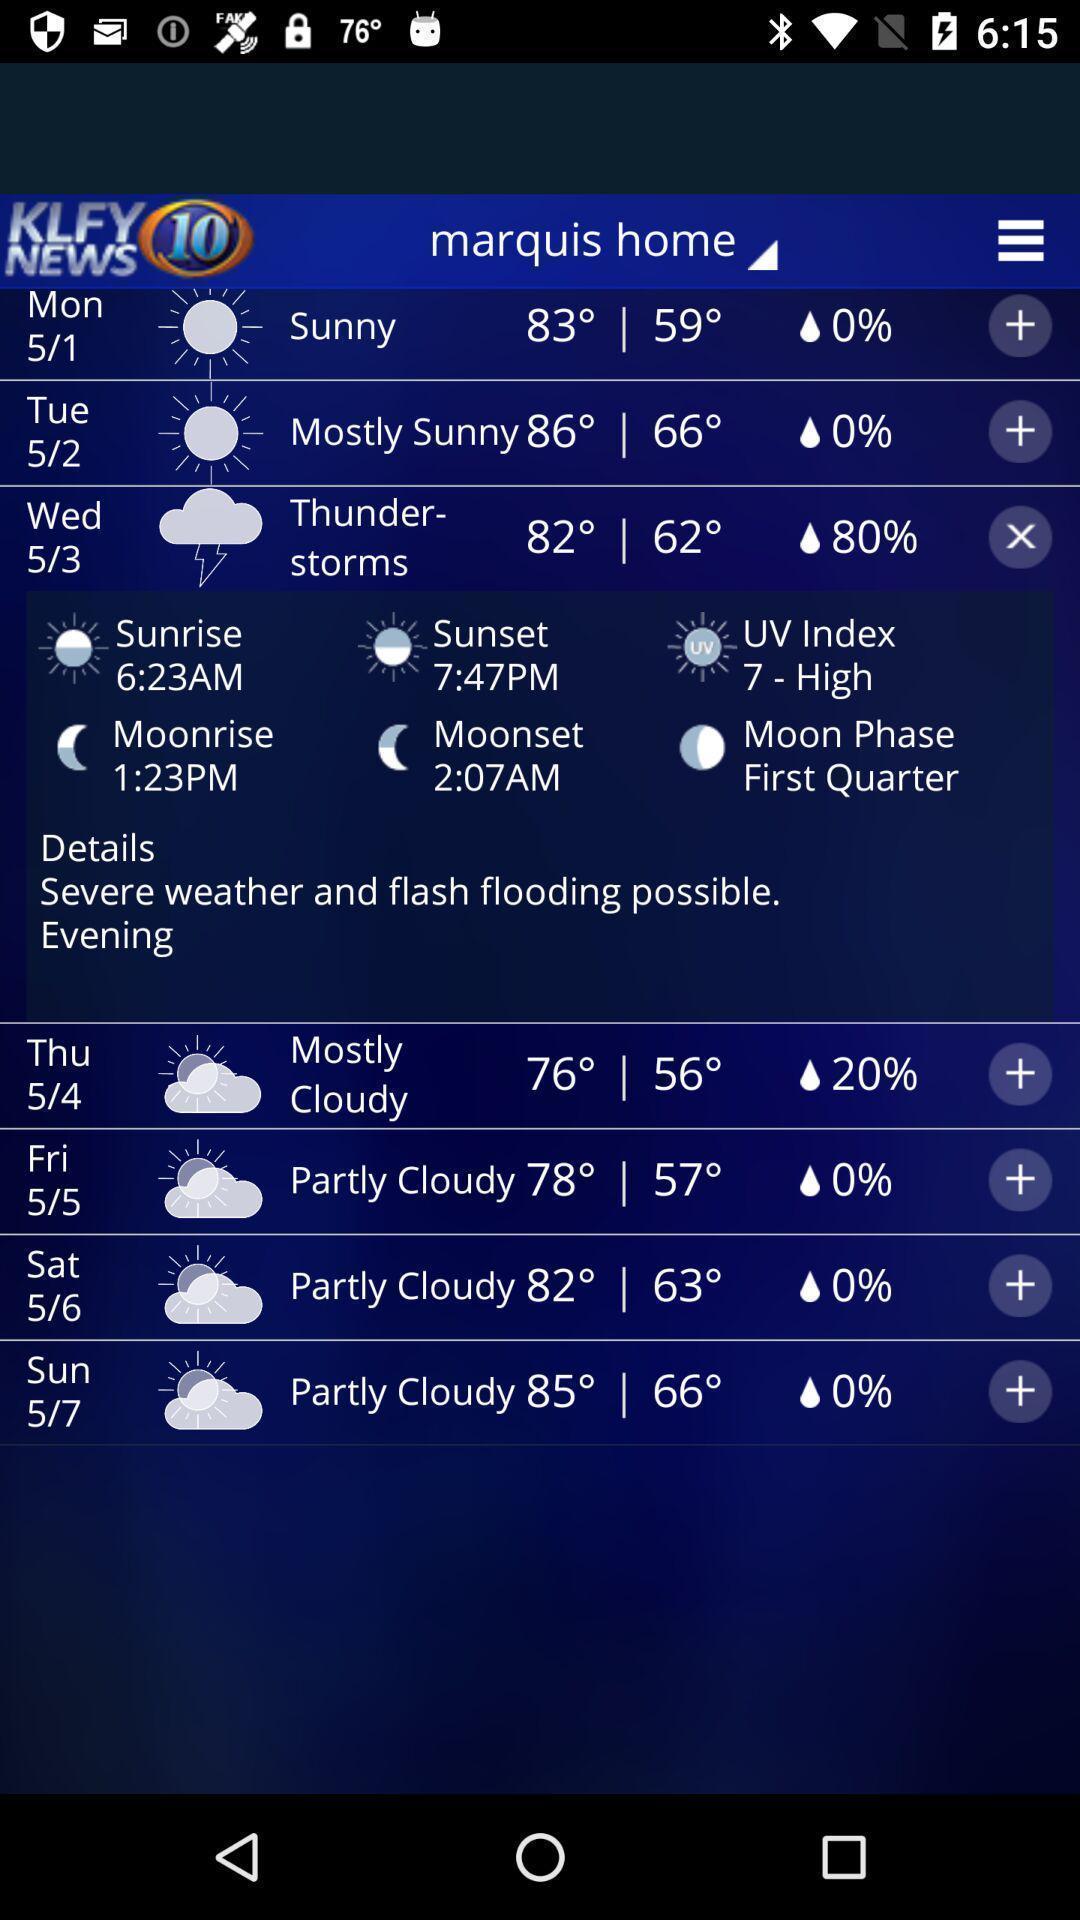Describe the content in this image. Screen display shows weather forecast application. 